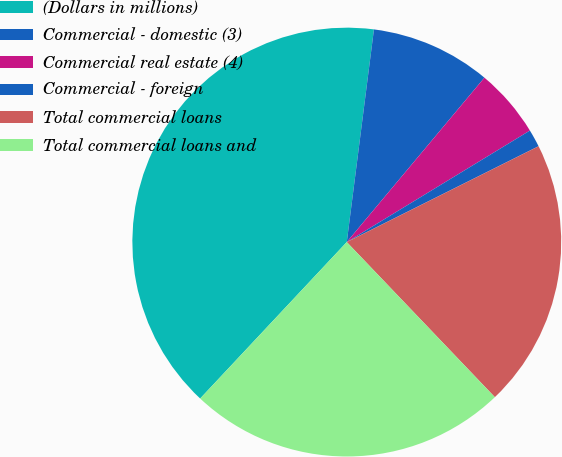Convert chart. <chart><loc_0><loc_0><loc_500><loc_500><pie_chart><fcel>(Dollars in millions)<fcel>Commercial - domestic (3)<fcel>Commercial real estate (4)<fcel>Commercial - foreign<fcel>Total commercial loans<fcel>Total commercial loans and<nl><fcel>40.03%<fcel>9.07%<fcel>5.2%<fcel>1.33%<fcel>20.24%<fcel>24.11%<nl></chart> 